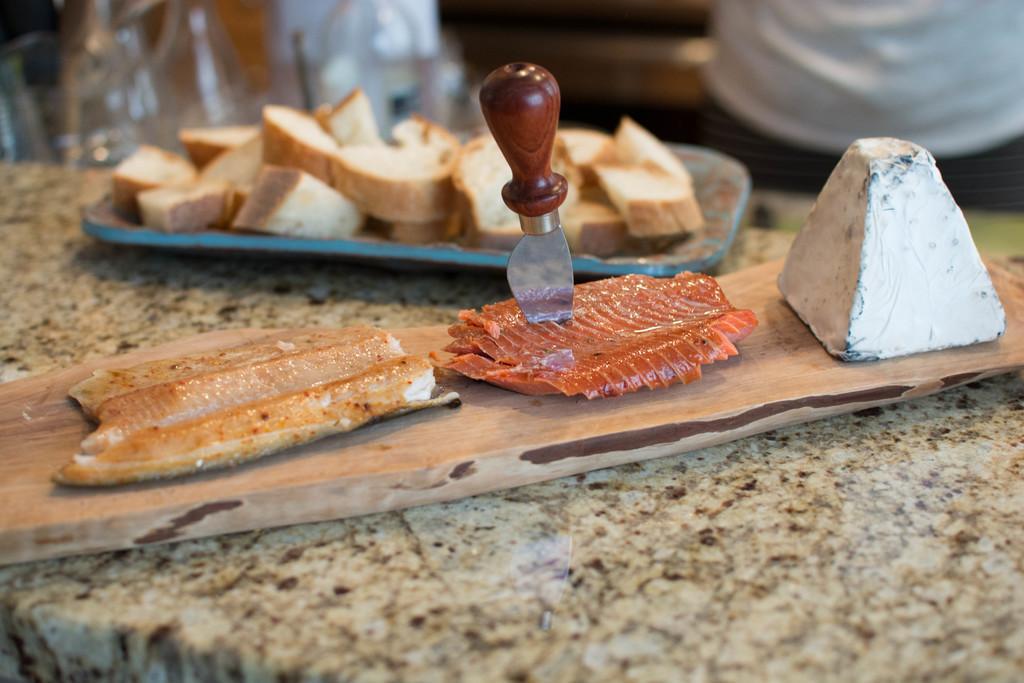Please provide a concise description of this image. In this picture I can see food items on the plate and on the wooden piece, there is a knife poked into one of the food item , which is on the wooden piece , and these are on the object, and there is blur background. 